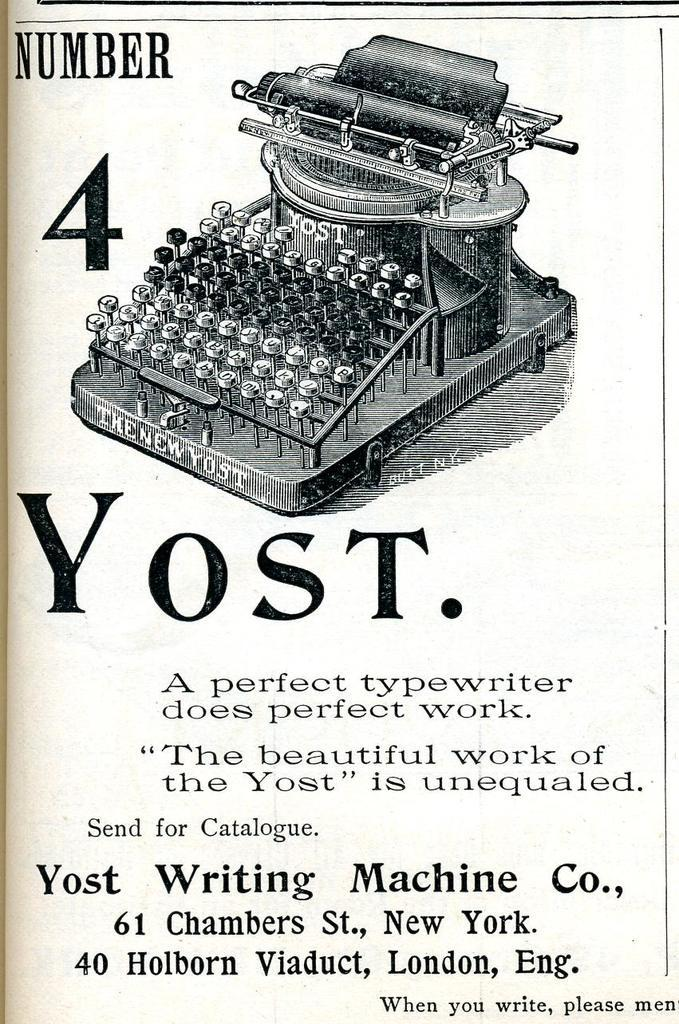What is depicted in the painting on the poster? The painting on the poster is of a typing machine. What color is the text on the poster? The text on the poster is black colored. What color are the numbers on the poster? The numbers on the poster are black colored. What is the color of the background on the poster? The background of the poster is white in color. How does the poster compare to a vinyl record in terms of sound production? The poster is not capable of producing sound, as it is a visual representation, and there is no mention of a vinyl record in the provided facts. 